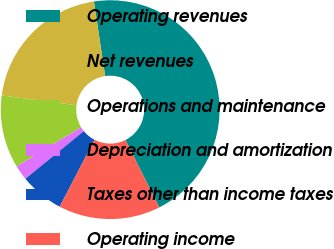Convert chart to OTSL. <chart><loc_0><loc_0><loc_500><loc_500><pie_chart><fcel>Operating revenues<fcel>Net revenues<fcel>Operations and maintenance<fcel>Depreciation and amortization<fcel>Taxes other than income taxes<fcel>Operating income<nl><fcel>44.98%<fcel>20.55%<fcel>10.76%<fcel>2.2%<fcel>6.48%<fcel>15.04%<nl></chart> 